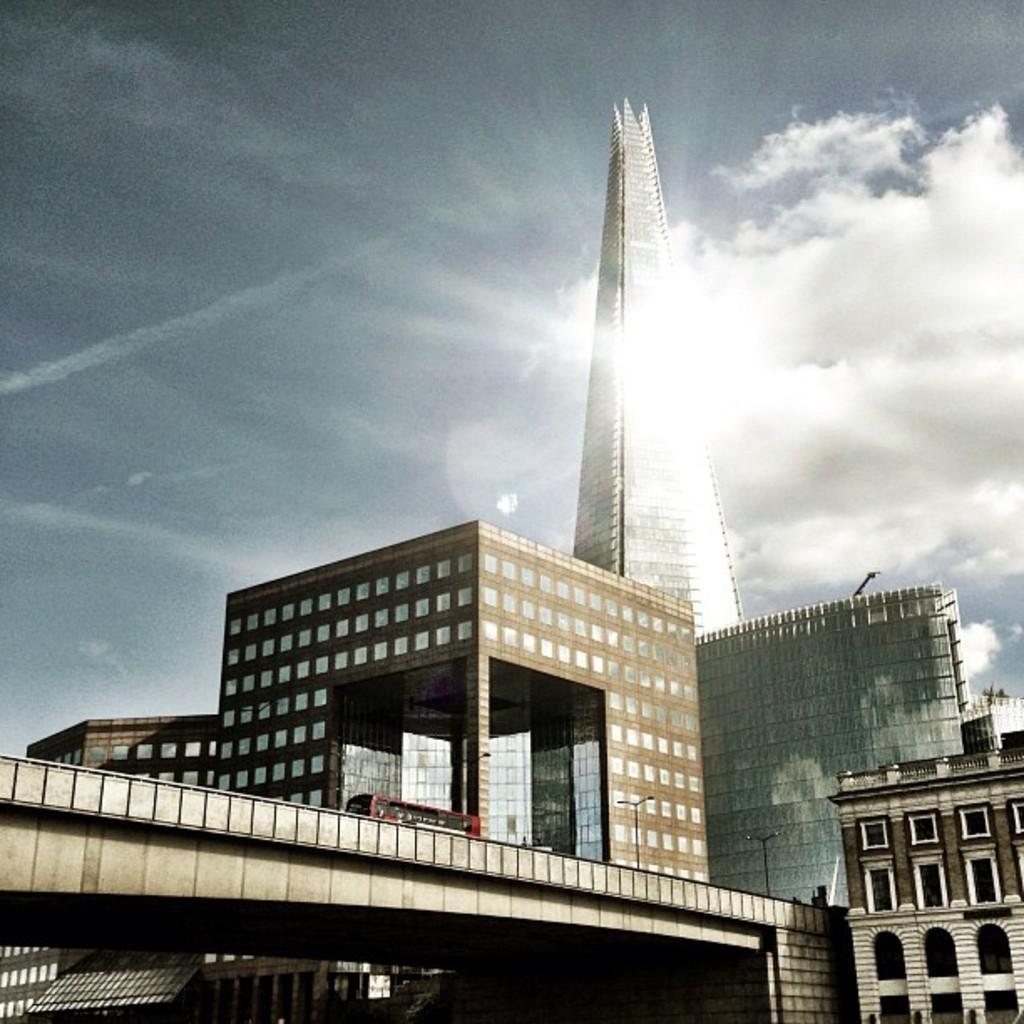Can you describe this image briefly? In the picture I can see the tower buildings and a bridge construction. I can see a red color bus on the bridge. I can see the light poles on the side of the road on the bridge. There are clouds in the sky. 